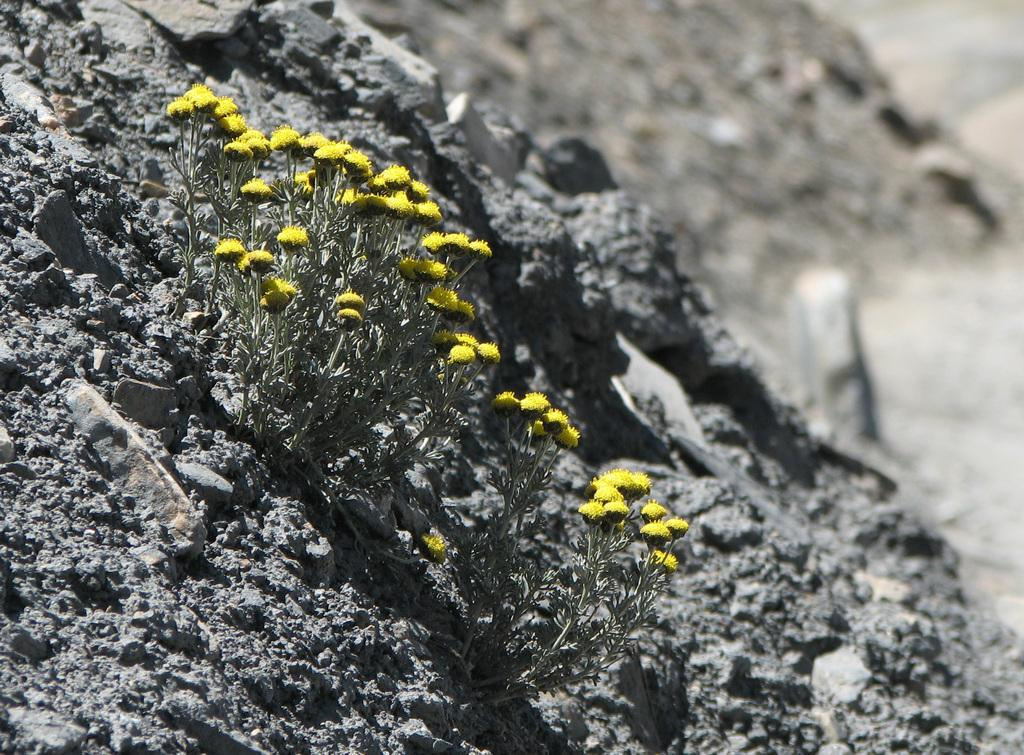What type of plants can be seen in the image? There are small plants in the image. What color are the flowers on the plants? The flowers on the plants are yellow. What is the surface on which the plants are placed? The plants are on sand. Can you describe the background of the image? The background of the image is blurred. What other elements can be seen on the ground in the background? Stones are visible on the ground in the background. What is the rate of growth for the plants in the image? There is no information provided about the rate of growth for the plants in the image. In which country can these plants be found? The image does not provide information about the country where these plants are located. 